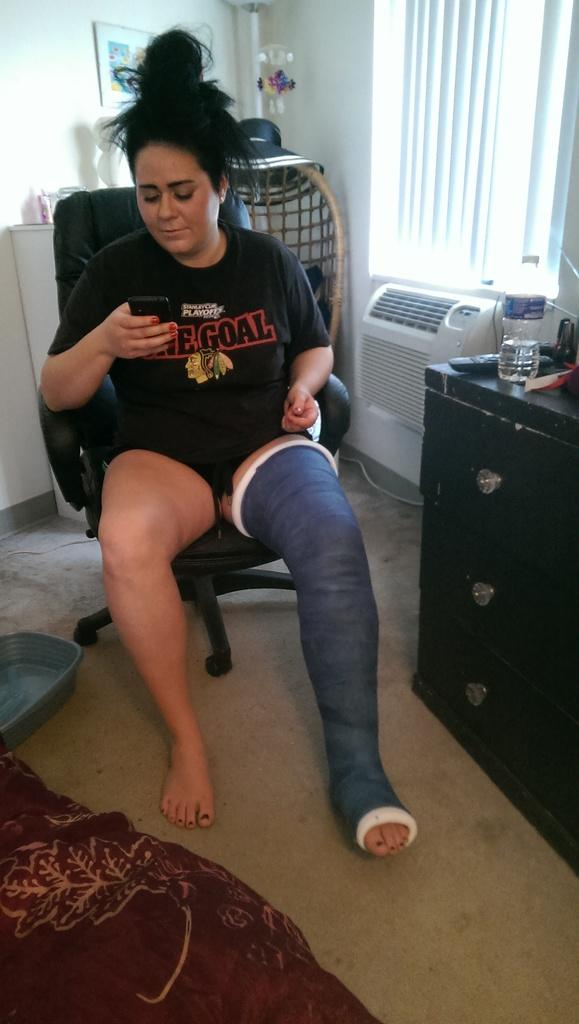Who is the main subject in the picture? There is a lady in the picture. What is the lady doing in the image? The lady is sitting on a chair. Can you describe any additional details about the lady? The lady has a band on her left leg. What type of mint is growing on the lady's back in the image? There is no mint or any plant growing on the lady's back in the image. 